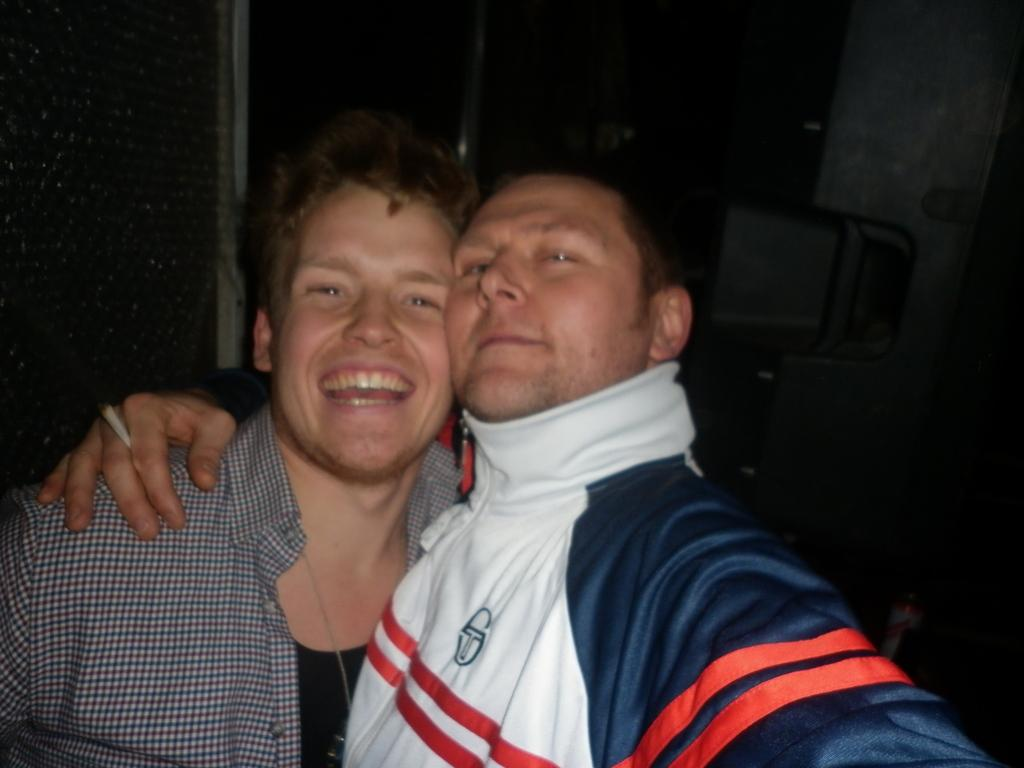Where was the image taken? The image is taken indoors. What can be seen in the background of the image? There is a wall in the background of the image. How many people are in the image? There are two men in the middle of the image. What is the facial expression of the men in the image? The men have smiling faces. What type of eggnog is being served in the image? There is no eggnog present in the image. Can you see any fairies in the image? There are no fairies present in the image. 